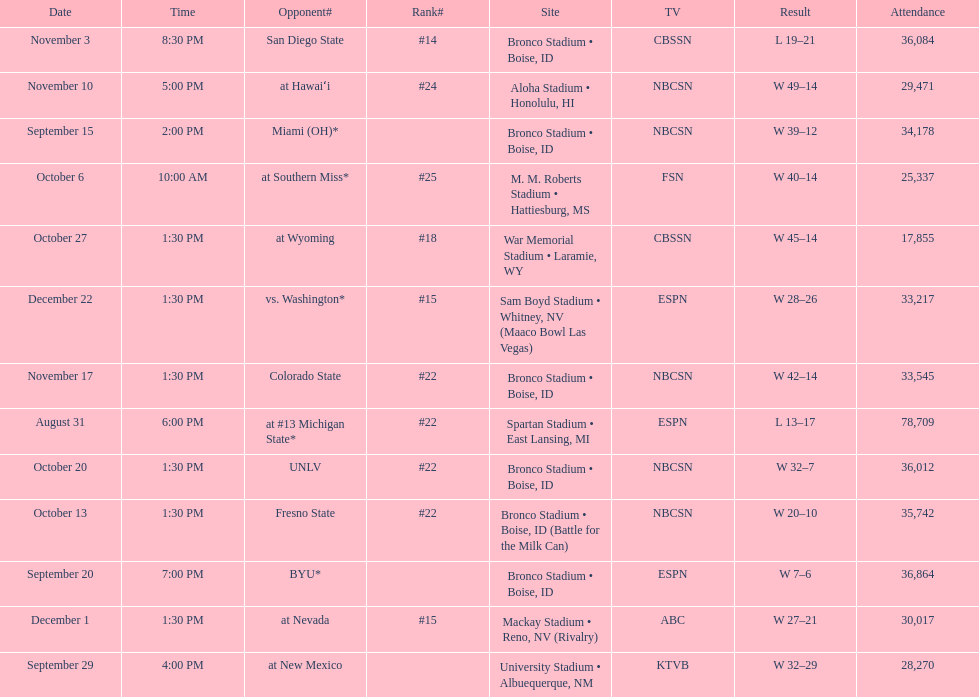What was the peak position they achieved in the season? #14. 